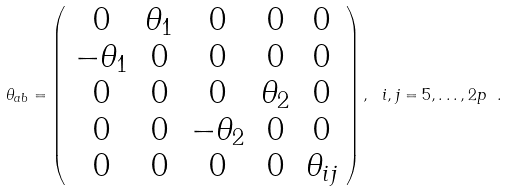<formula> <loc_0><loc_0><loc_500><loc_500>\theta _ { a b } = \left ( \begin{array} { c c c c c } { 0 } & { { \theta _ { 1 } } } & { 0 } & { 0 } & { 0 } \\ { { - \theta _ { 1 } } } & { 0 } & { 0 } & { 0 } & { 0 } \\ { 0 } & { 0 } & { 0 } & { { \theta _ { 2 } } } & { 0 } \\ { 0 } & { 0 } & { { - \theta _ { 2 } } } & { 0 } & { 0 } \\ { 0 } & { 0 } & { 0 } & { 0 } & { { \theta _ { i j } } } \end{array} \right ) , \ i , j = 5 , \dots , 2 p \ .</formula> 